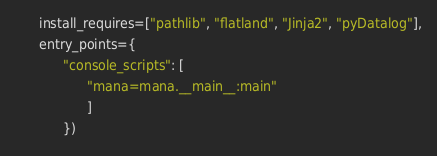<code> <loc_0><loc_0><loc_500><loc_500><_Python_>      install_requires=["pathlib", "flatland", "Jinja2", "pyDatalog"],
      entry_points={
            "console_scripts": [
                  "mana=mana.__main__:main"
                  ]
            })
</code> 